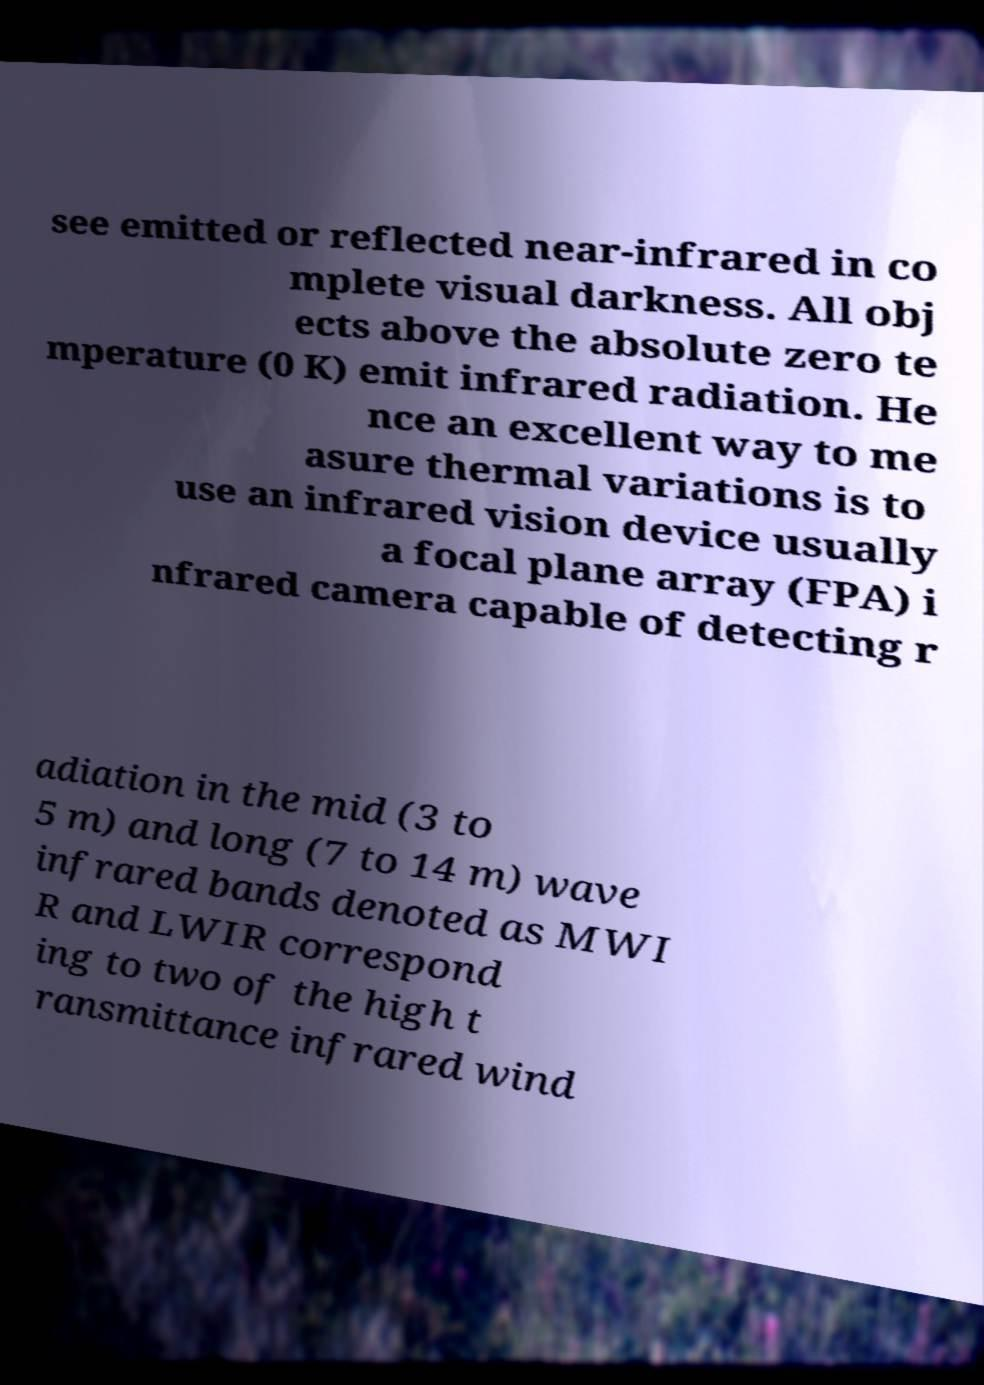Can you read and provide the text displayed in the image?This photo seems to have some interesting text. Can you extract and type it out for me? see emitted or reflected near-infrared in co mplete visual darkness. All obj ects above the absolute zero te mperature (0 K) emit infrared radiation. He nce an excellent way to me asure thermal variations is to use an infrared vision device usually a focal plane array (FPA) i nfrared camera capable of detecting r adiation in the mid (3 to 5 m) and long (7 to 14 m) wave infrared bands denoted as MWI R and LWIR correspond ing to two of the high t ransmittance infrared wind 